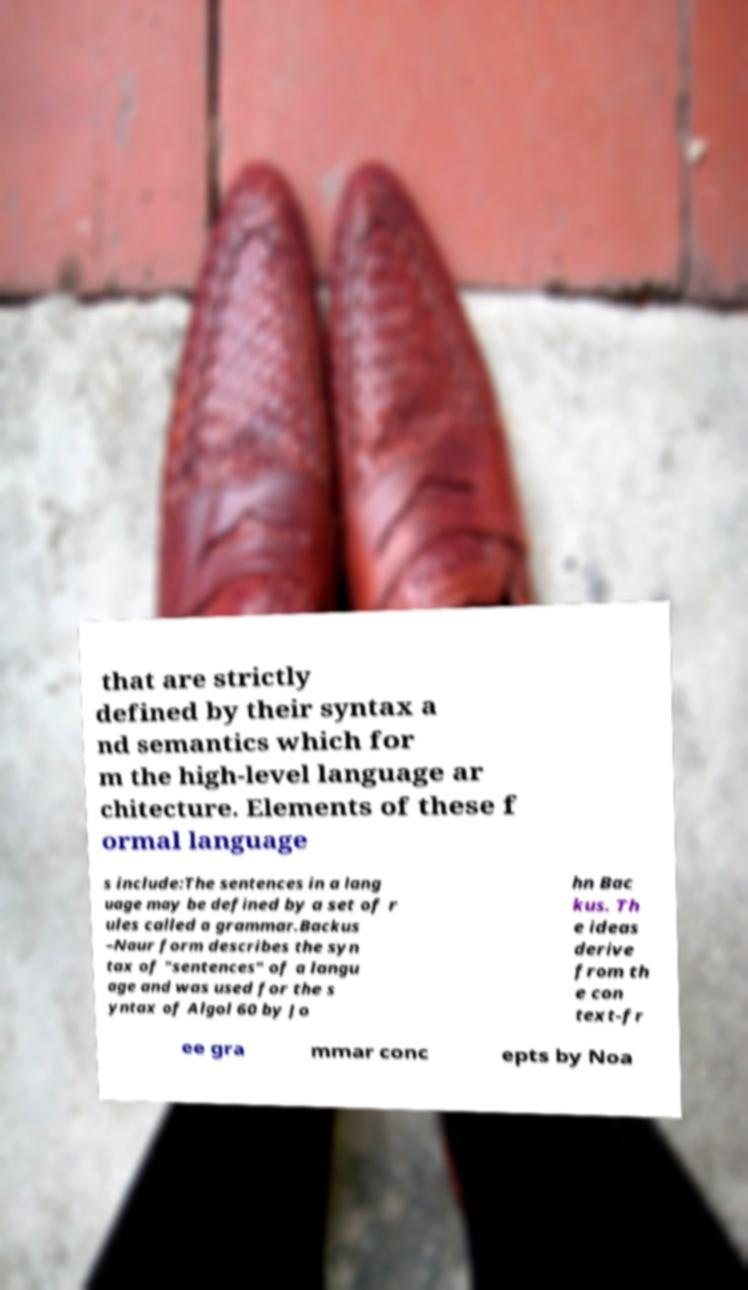Please identify and transcribe the text found in this image. that are strictly defined by their syntax a nd semantics which for m the high-level language ar chitecture. Elements of these f ormal language s include:The sentences in a lang uage may be defined by a set of r ules called a grammar.Backus –Naur form describes the syn tax of "sentences" of a langu age and was used for the s yntax of Algol 60 by Jo hn Bac kus. Th e ideas derive from th e con text-fr ee gra mmar conc epts by Noa 